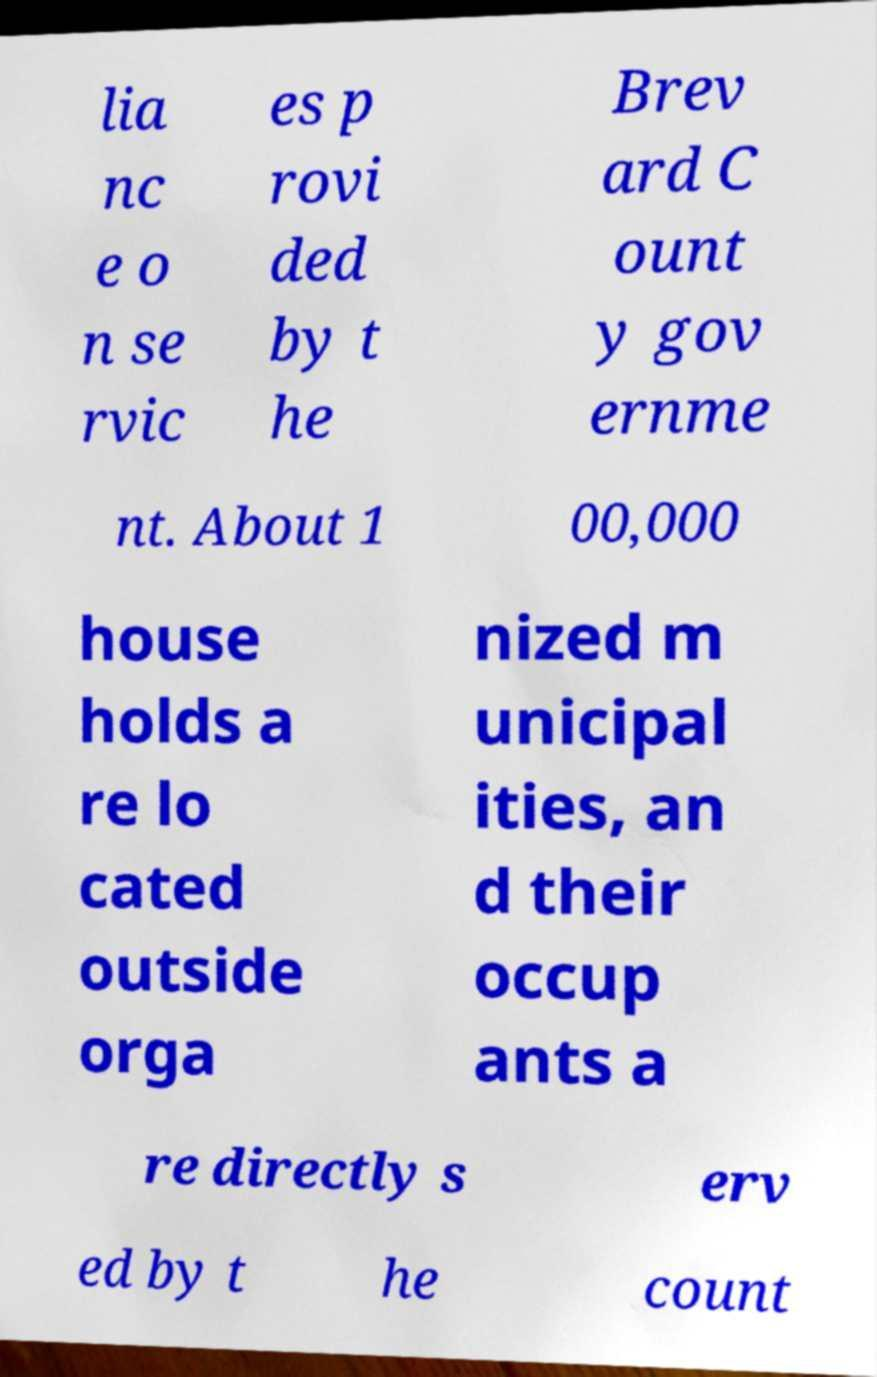Please identify and transcribe the text found in this image. lia nc e o n se rvic es p rovi ded by t he Brev ard C ount y gov ernme nt. About 1 00,000 house holds a re lo cated outside orga nized m unicipal ities, an d their occup ants a re directly s erv ed by t he count 